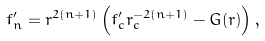Convert formula to latex. <formula><loc_0><loc_0><loc_500><loc_500>f _ { n } ^ { \prime } = r ^ { 2 ( n + 1 ) } \left ( f _ { c } ^ { \prime } r _ { c } ^ { - 2 ( n + 1 ) } - G ( r ) \right ) ,</formula> 